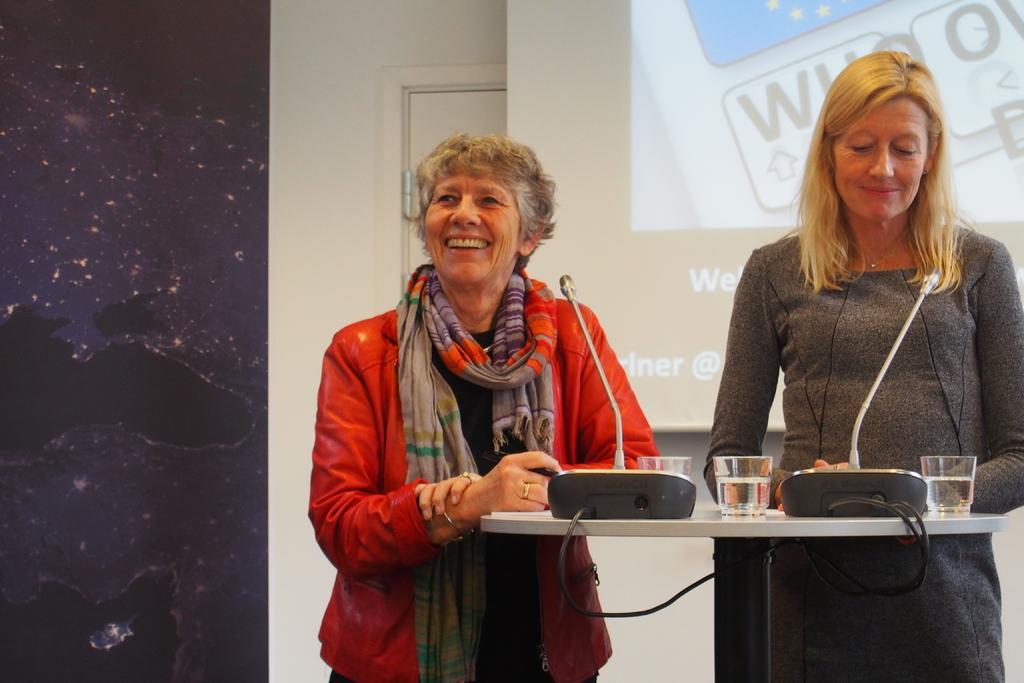In one or two sentences, can you explain what this image depicts? In the image in the center we can see two persons were standing and they were smiling,which we can see on their faces. In front of them,there is a table. On table,we can see glasses,microphones and link boxes. In the background we can see wall,door and screen. 